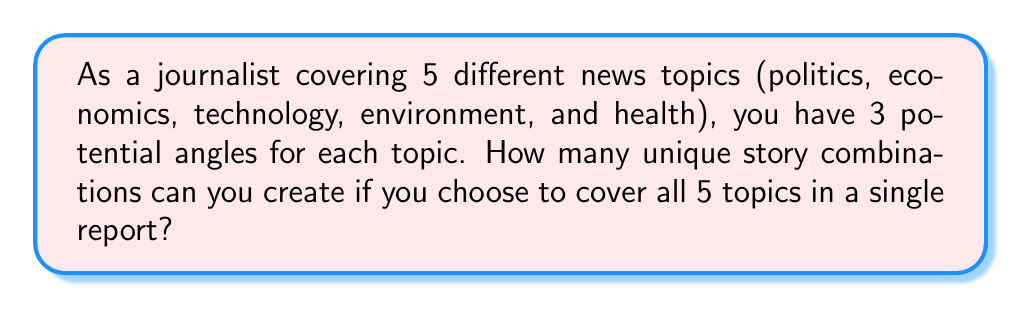Give your solution to this math problem. Let's approach this step-by-step:

1) We have 5 news topics, and for each topic, we have 3 potential angles.

2) For each topic, we need to choose one angle out of the three available. This is equivalent to making 5 independent choices, one for each topic.

3) When we have independent choices, we multiply the number of options for each choice. This is where exponents come in handy.

4) We can express this mathematically as:

   $$ \text{Total combinations} = 3^5 $$

   This is because we have 3 choices for each of the 5 topics.

5) Let's calculate this:

   $$ 3^5 = 3 \times 3 \times 3 \times 3 \times 3 = 243 $$

6) Therefore, there are 243 unique story combinations possible.

This exponential calculation efficiently represents the multiplicity of choices across multiple categories, which is a common scenario in journalism when covering multiple topics.
Answer: $3^5 = 243$ combinations 